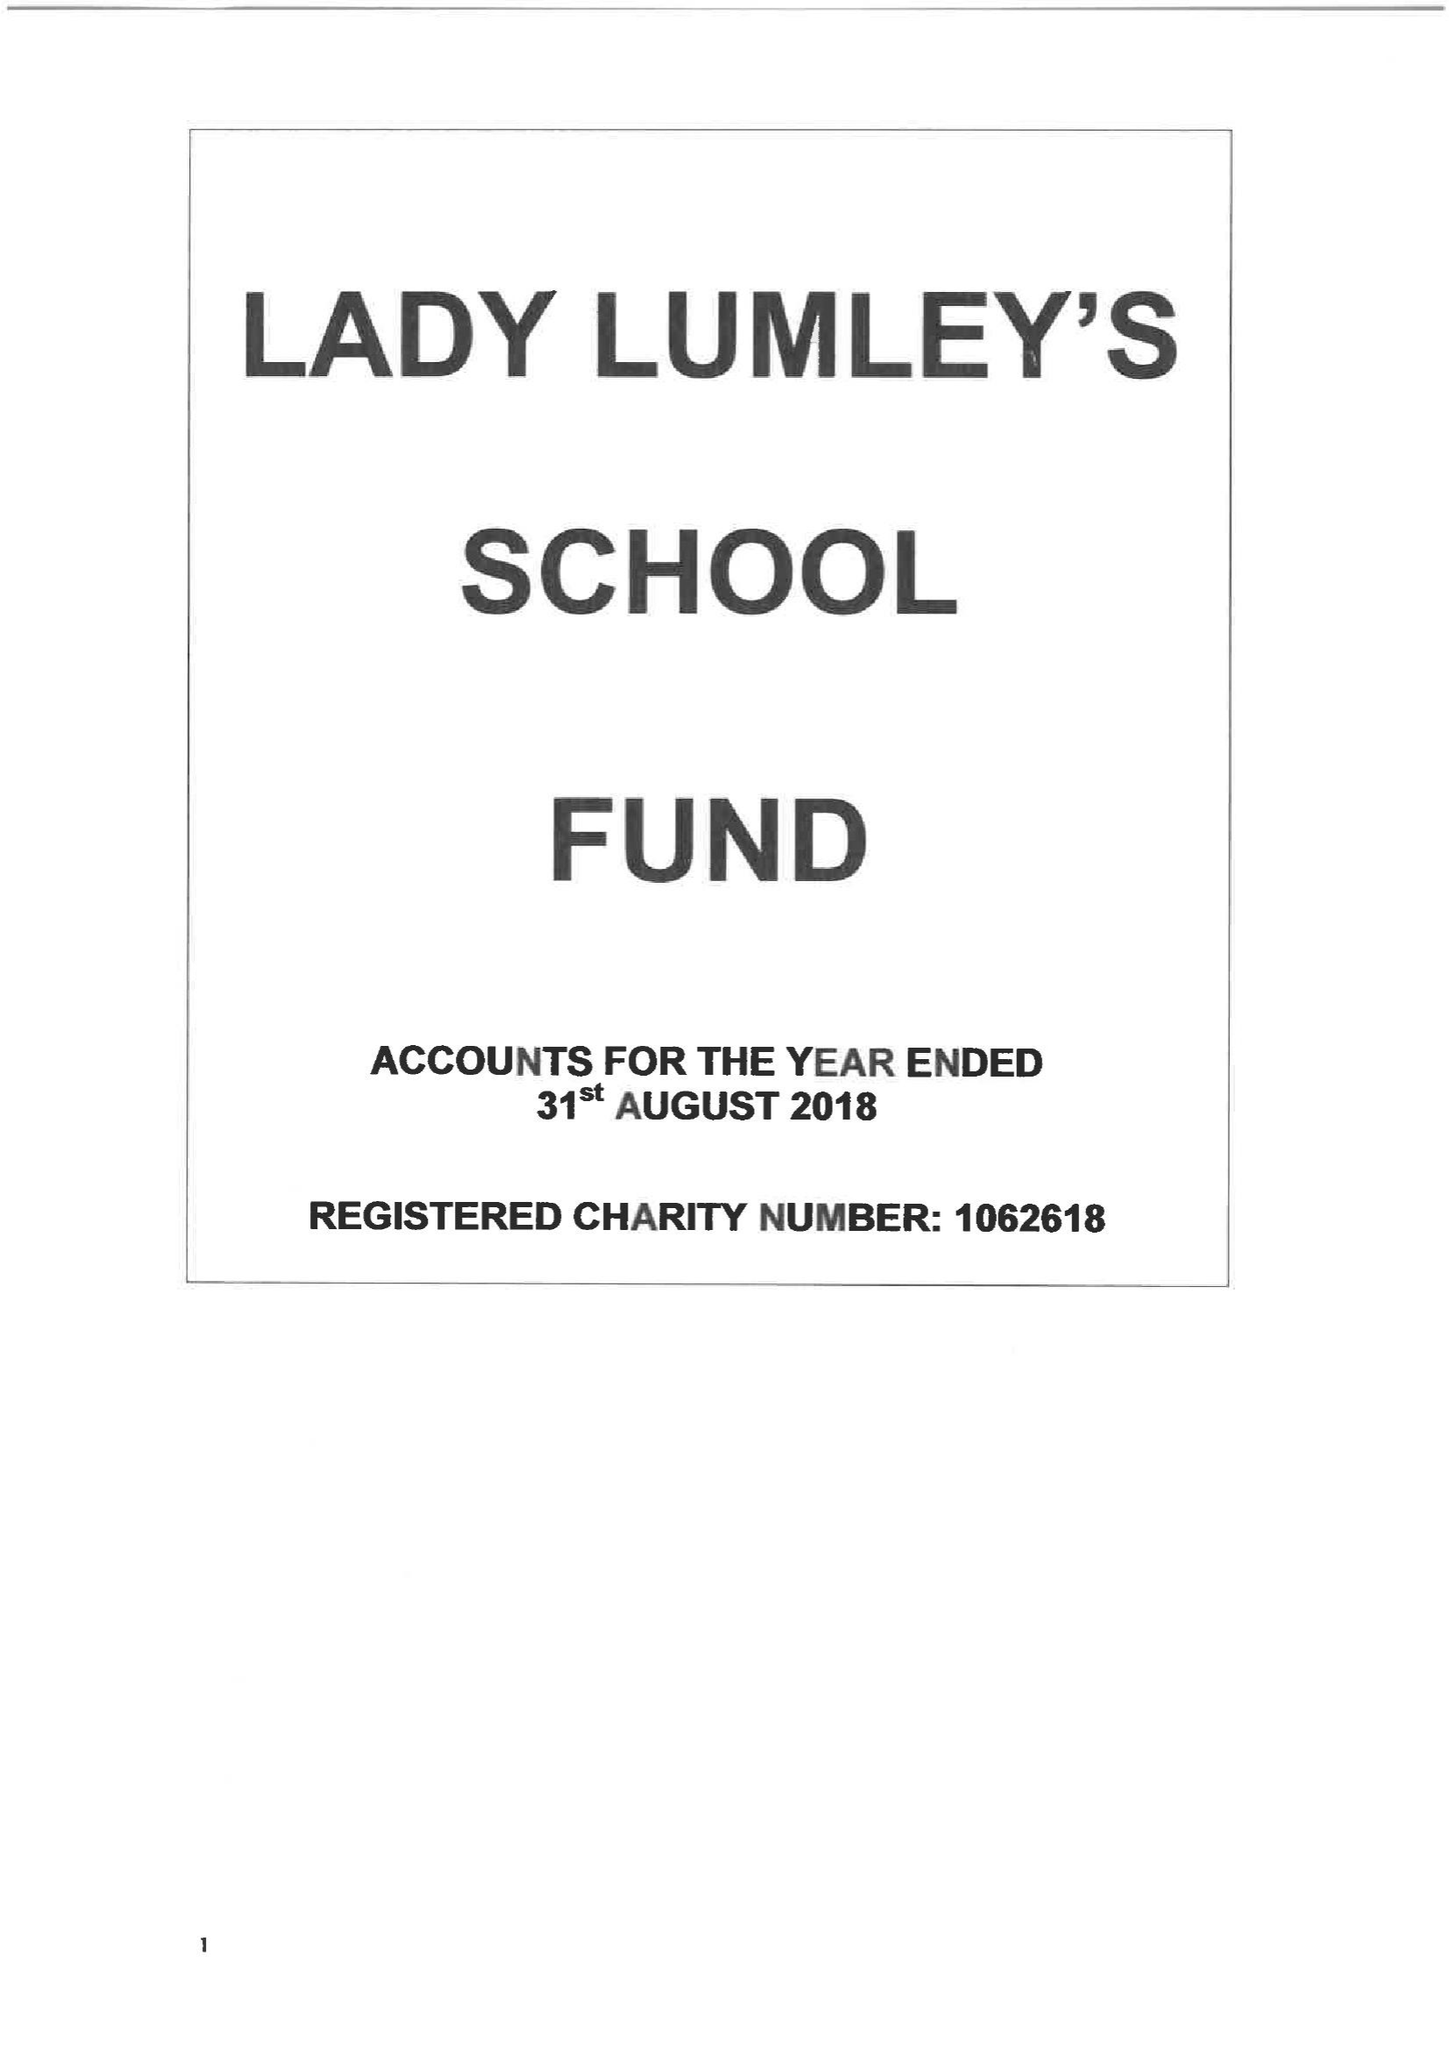What is the value for the income_annually_in_british_pounds?
Answer the question using a single word or phrase. 49554.00 